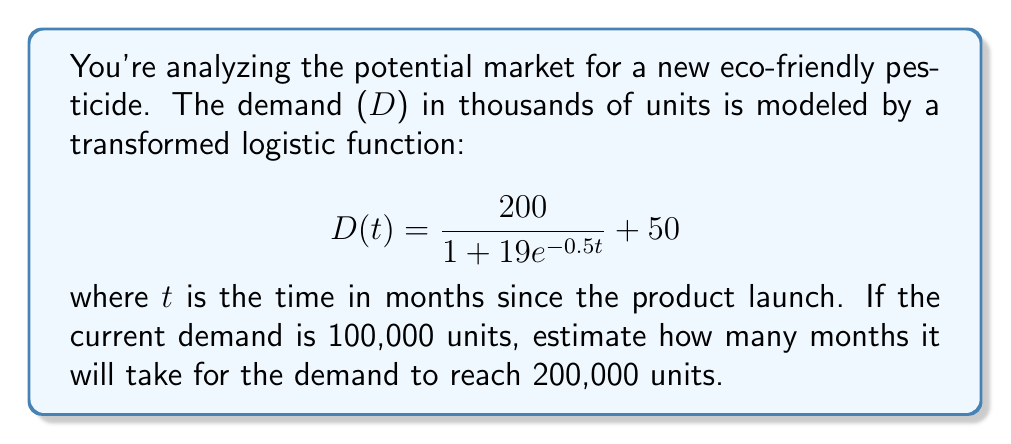Provide a solution to this math problem. 1) First, we need to find the current time t when demand is 100,000 units:

   $$100 = \frac{200}{1 + 19e^{-0.5t}} + 50$$

2) Subtract 50 from both sides:

   $$50 = \frac{200}{1 + 19e^{-0.5t}}$$

3) Multiply both sides by $(1 + 19e^{-0.5t})$:

   $$50(1 + 19e^{-0.5t}) = 200$$

4) Divide by 50:

   $$1 + 19e^{-0.5t} = 4$$

5) Subtract 1 from both sides:

   $$19e^{-0.5t} = 3$$

6) Divide by 19:

   $$e^{-0.5t} = \frac{3}{19}$$

7) Take the natural log of both sides:

   $$-0.5t = \ln(\frac{3}{19})$$

8) Divide by -0.5:

   $$t = -2\ln(\frac{3}{19}) \approx 3.71$$ months

9) Now, we need to find when demand reaches 200,000 units:

   $$200 = \frac{200}{1 + 19e^{-0.5t}} + 50$$

10) Following similar steps as above, we get:

    $$t = -2\ln(\frac{1}{19}) \approx 11.78$$ months

11) The difference between these times is approximately:

    $$11.78 - 3.71 = 8.07$$ months
Answer: 8.07 months 